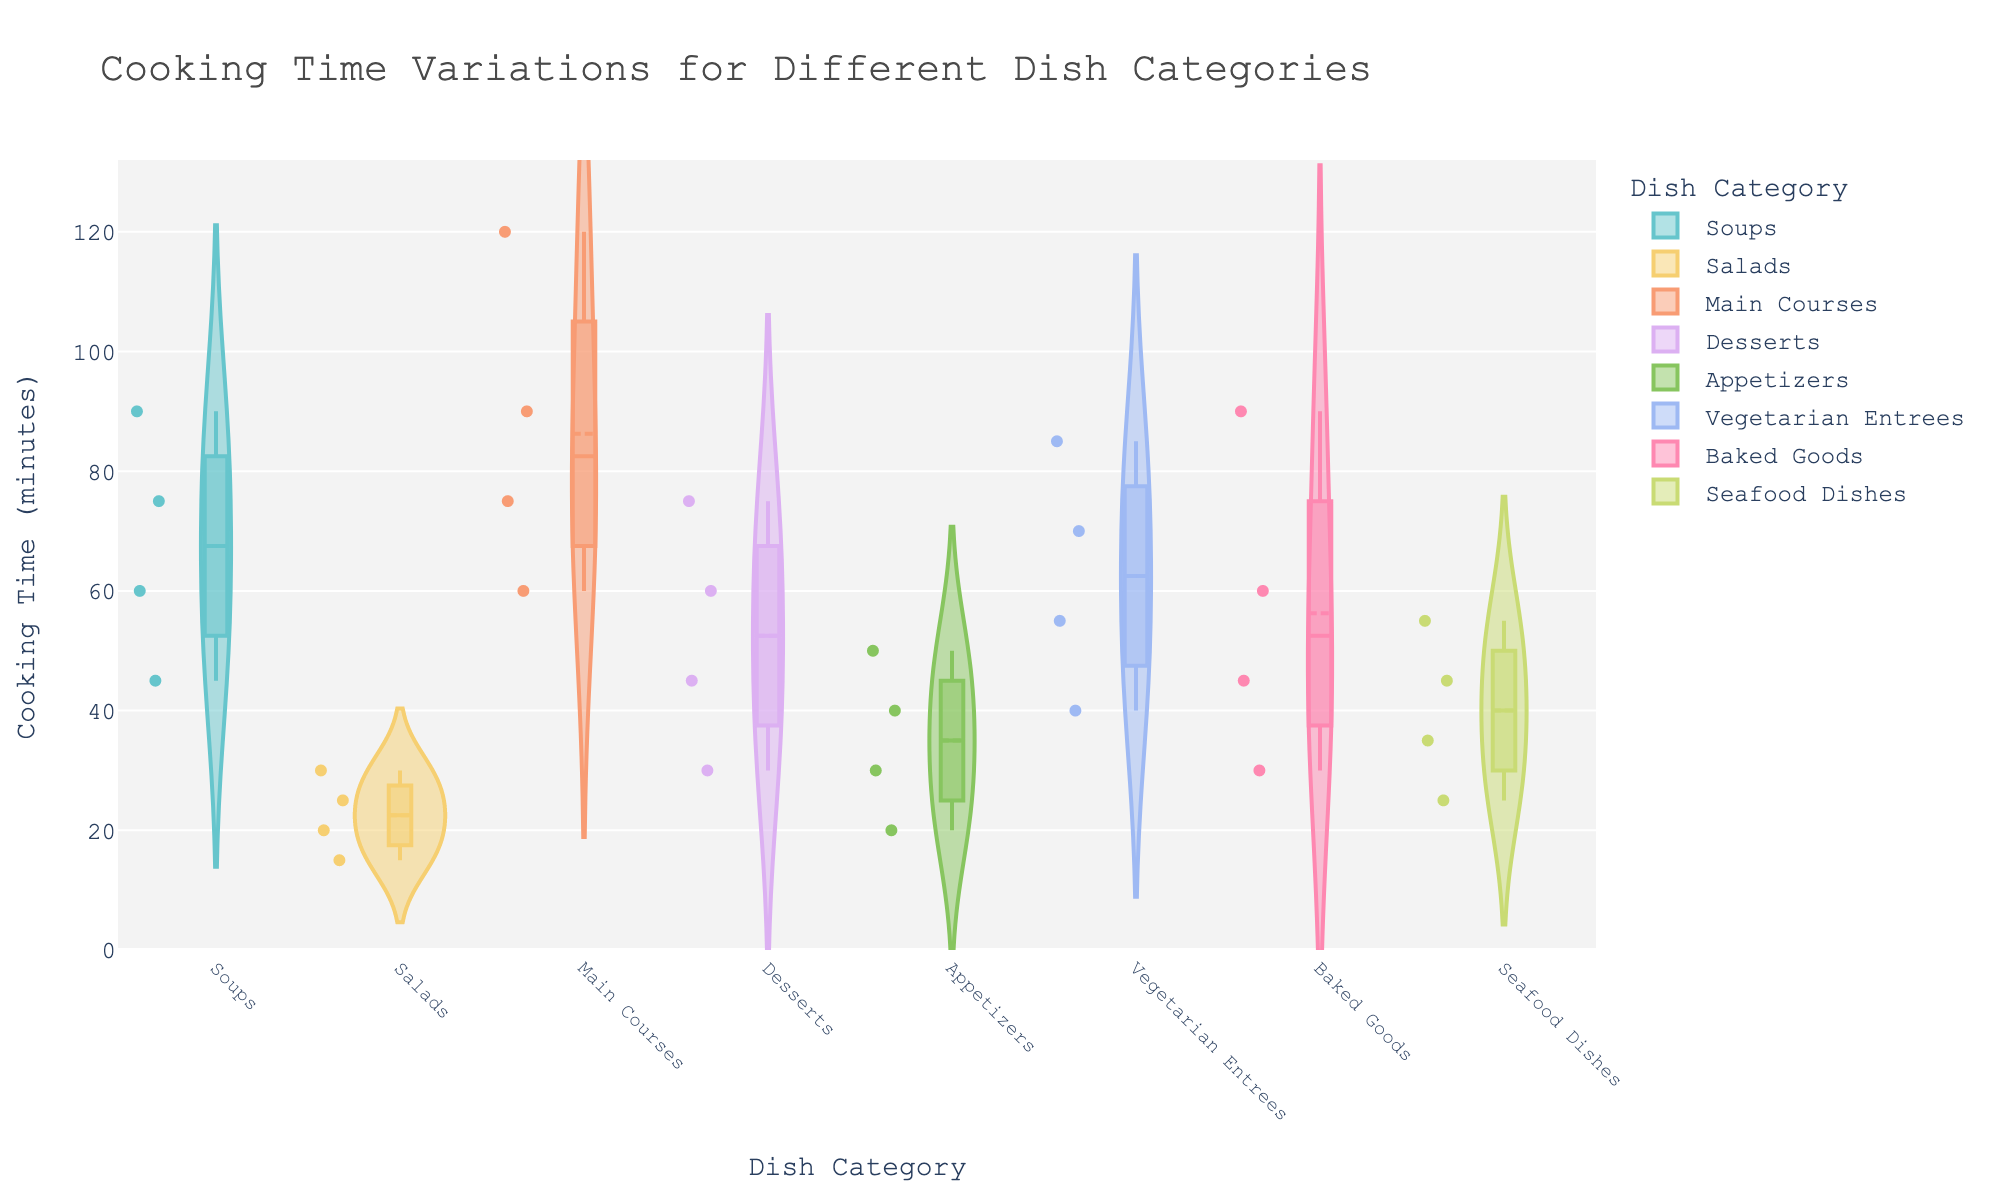Which dish category has the longest cooking time? By examining the density plot, look for the category with the highest value on the y-axis.
Answer: Main Courses How many cooking time data points are represented for Main Courses? Count the individual points within the Main Courses violin plot.
Answer: 4 What is the median cooking time for Soups? Identify the line in the box that represents the median.
Answer: 67.5 minutes Compare the average cooking times of Salads and Appetizers. Which category has a higher average? Calculate the average cooking time for each category: (15+20+25+30)/4 for Salads and (20+30+40+50)/4 for Appetizers.
Answer: Appetizers What is the range of cooking times for Baked Goods? Determine the minimum and maximum cooking times within the Baked Goods category and subtract the smallest value from the largest.
Answer: 60 minutes (90 - 30) Which dish category has the most varied cooking times? The category with the widest spread in the violin plot has the most variation.
Answer: Soups Are there any categories where the cooking times are close to each other? Look for categories where cooking times fall within a narrow range.
Answer: Salads and Appetizers What is the mean cooking time for Vegetarian Entrees? Sum the cooking times for Vegetarian Entrees and divide by the number of data points: (40+55+70+85)/4.
Answer: 62.5 minutes Between Desserts and Seafood Dishes, which has a more consistent cooking time? Compare the spread and box size of the violin plots.
Answer: Seafood Dishes 